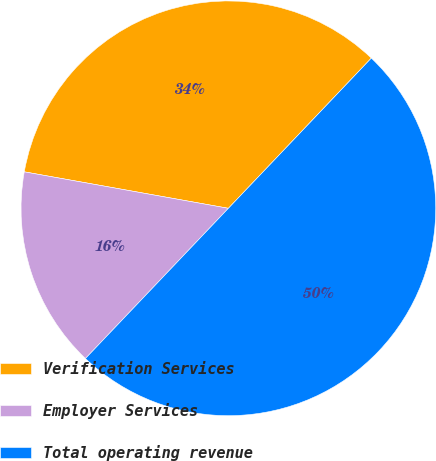<chart> <loc_0><loc_0><loc_500><loc_500><pie_chart><fcel>Verification Services<fcel>Employer Services<fcel>Total operating revenue<nl><fcel>34.29%<fcel>15.71%<fcel>50.0%<nl></chart> 